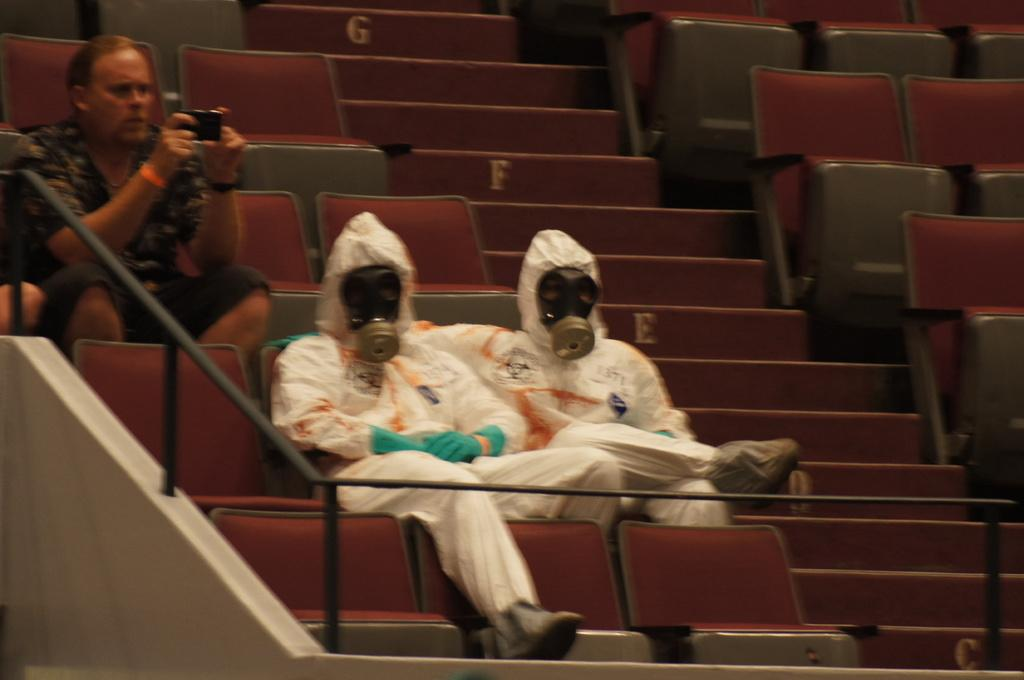How many people are sitting in the image? There are two persons sitting on chairs in the image. What are the people wearing? The persons are wearing white dresses. Can you describe the man's position in the image? The man is on the left side of the image. What is the man holding in the image? The man is holding a mobile phone. What is the man doing with the mobile phone? The man is using the mobile phone to take a photo or record a video. How many times does the man sneeze while taking the photo or recording the video? There is no indication in the image that the man is sneezing, so it cannot be determined from the picture. What is the man's level of expertise in photography or videography? The image does not provide any information about the man's level of expertise in photography or videography. 